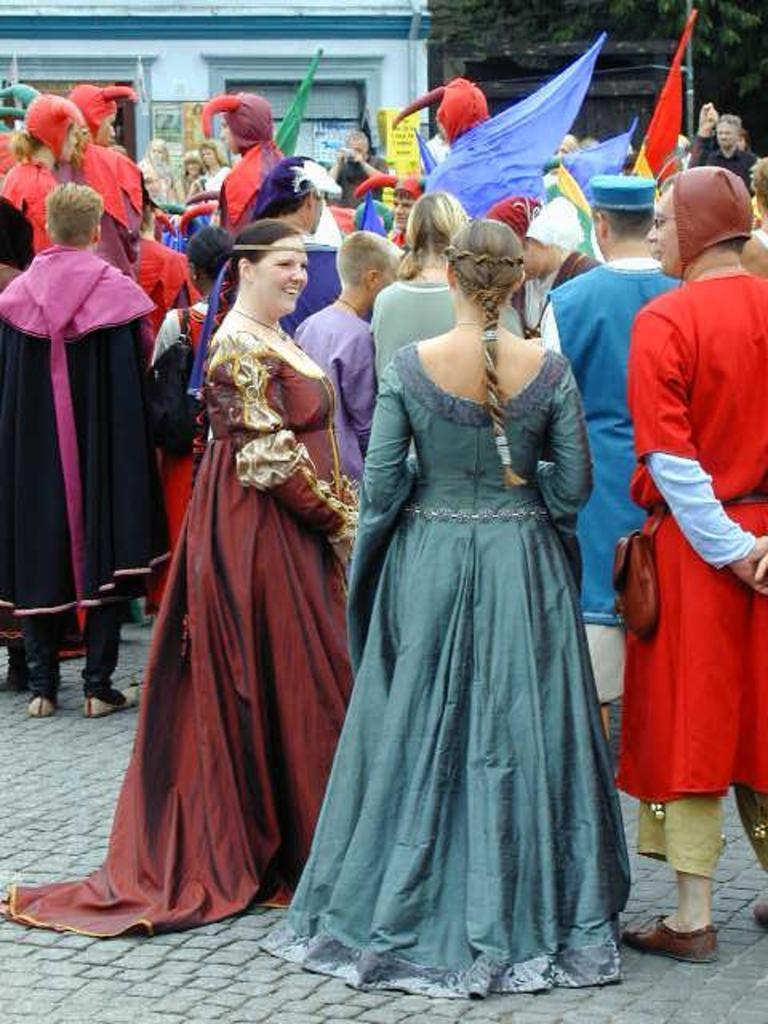Can you describe this image briefly? In the foreground of this picture, there are two women and a men standing and talking to each other. In the background, there is the crowd standing and holding flags in their hand, a building and a tree. 